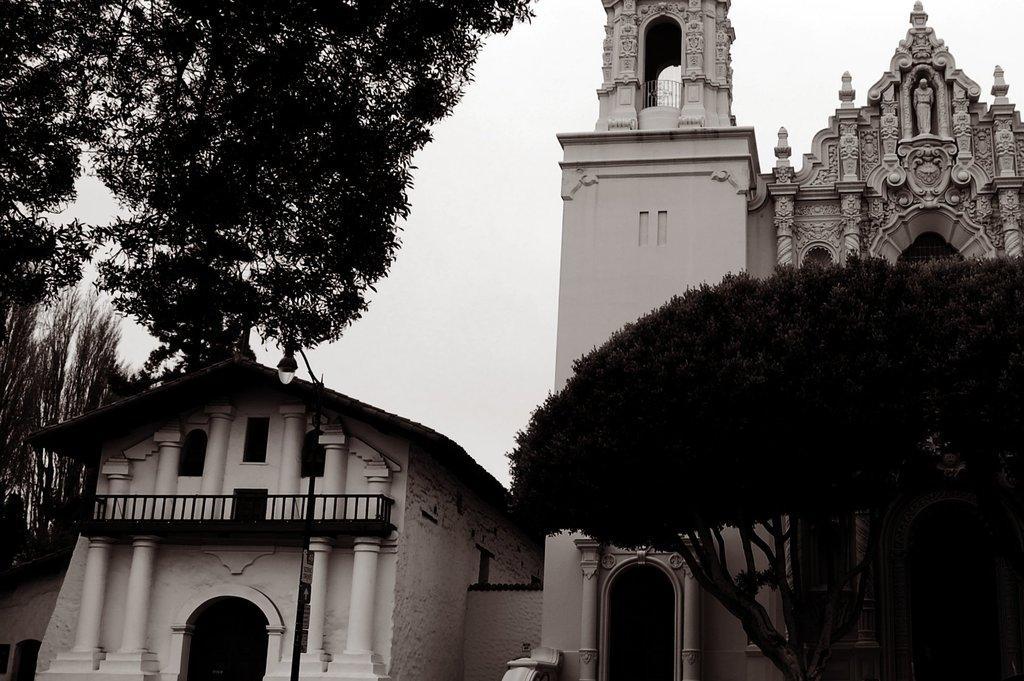Please provide a concise description of this image. In this image we can see buildings, trees, pillars, pole, light, and boards. In the background there is sky. 